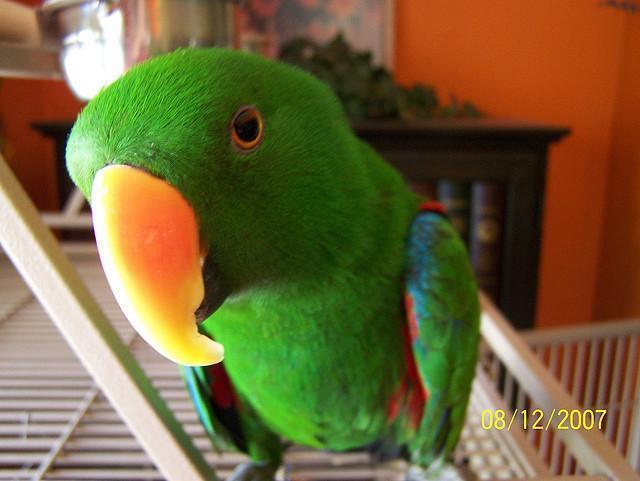Which bird can grind their own calcium supplements?
Select the accurate answer and provide justification: `Answer: choice
Rationale: srationale.`
Options: Peacock, dove, parrot, crow. Answer: parrot.
Rationale: The bird is the parrot. 